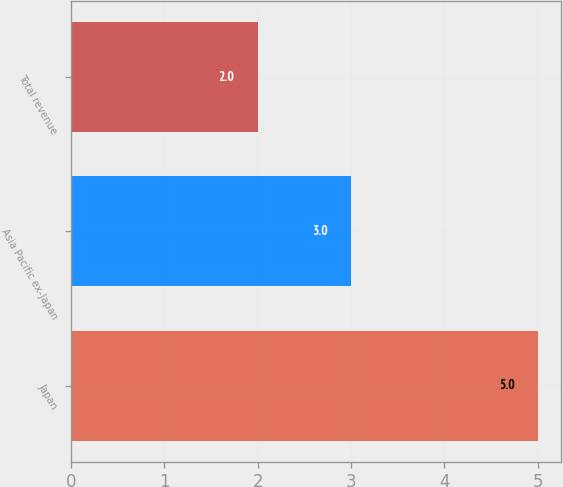Convert chart to OTSL. <chart><loc_0><loc_0><loc_500><loc_500><bar_chart><fcel>Japan<fcel>Asia Pacific ex-Japan<fcel>Total revenue<nl><fcel>5<fcel>3<fcel>2<nl></chart> 